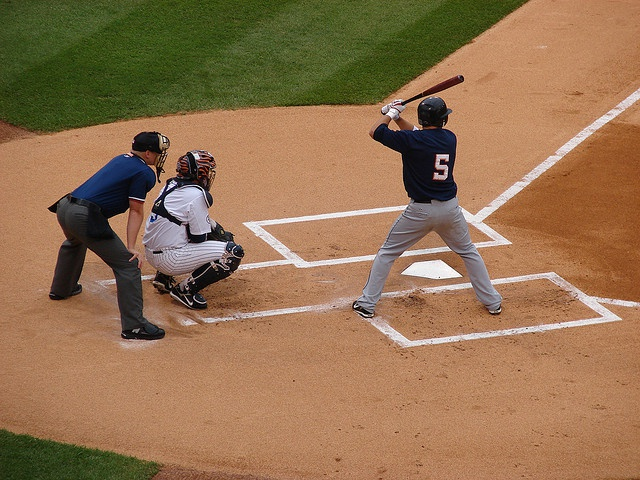Describe the objects in this image and their specific colors. I can see people in darkgreen, black, gray, and darkgray tones, people in darkgreen, black, navy, brown, and maroon tones, people in darkgreen, black, darkgray, gray, and lavender tones, and baseball glove in darkgreen, black, and gray tones in this image. 